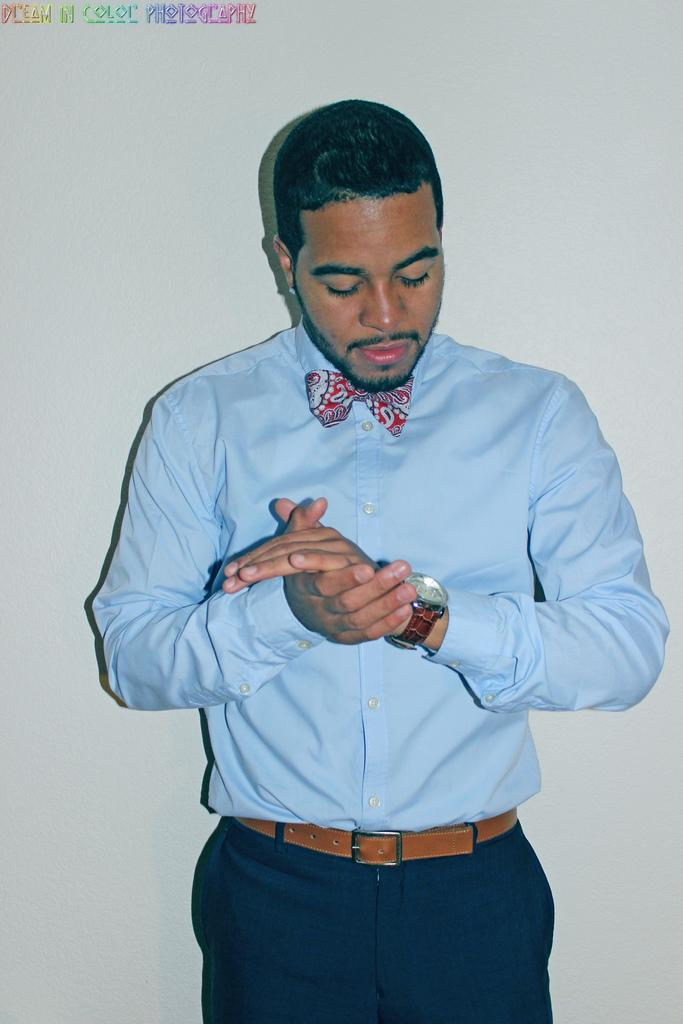What is the main subject of the image? There is a person in the image. What accessory can be seen on the person? There is a wrist watch in the image. What is written or displayed at the top of the image? There is some text at the top of the image. What color is the background of the image? The background of the image is white. What type of desk can be seen in the image? There is no desk present in the image. How is the person using the fork in the image? There is no fork present in the image. 